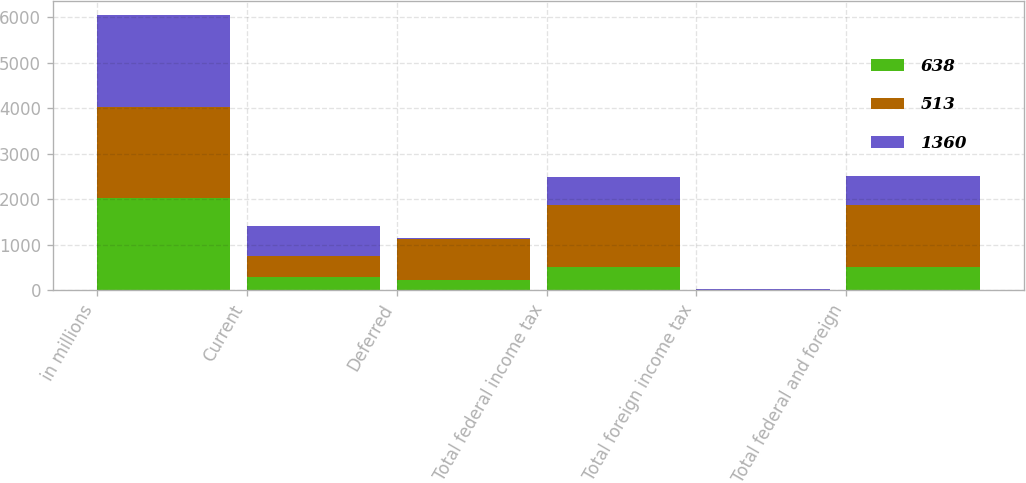<chart> <loc_0><loc_0><loc_500><loc_500><stacked_bar_chart><ecel><fcel>in millions<fcel>Current<fcel>Deferred<fcel>Total federal income tax<fcel>Total foreign income tax<fcel>Total federal and foreign<nl><fcel>638<fcel>2018<fcel>292<fcel>213<fcel>505<fcel>8<fcel>513<nl><fcel>513<fcel>2017<fcel>449<fcel>907<fcel>1356<fcel>4<fcel>1360<nl><fcel>1360<fcel>2016<fcel>661<fcel>36<fcel>625<fcel>13<fcel>638<nl></chart> 